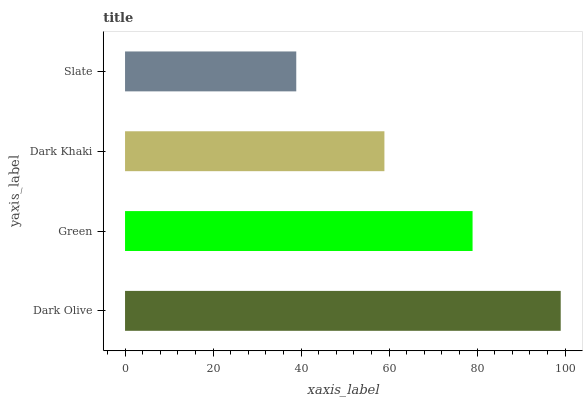Is Slate the minimum?
Answer yes or no. Yes. Is Dark Olive the maximum?
Answer yes or no. Yes. Is Green the minimum?
Answer yes or no. No. Is Green the maximum?
Answer yes or no. No. Is Dark Olive greater than Green?
Answer yes or no. Yes. Is Green less than Dark Olive?
Answer yes or no. Yes. Is Green greater than Dark Olive?
Answer yes or no. No. Is Dark Olive less than Green?
Answer yes or no. No. Is Green the high median?
Answer yes or no. Yes. Is Dark Khaki the low median?
Answer yes or no. Yes. Is Dark Olive the high median?
Answer yes or no. No. Is Dark Olive the low median?
Answer yes or no. No. 